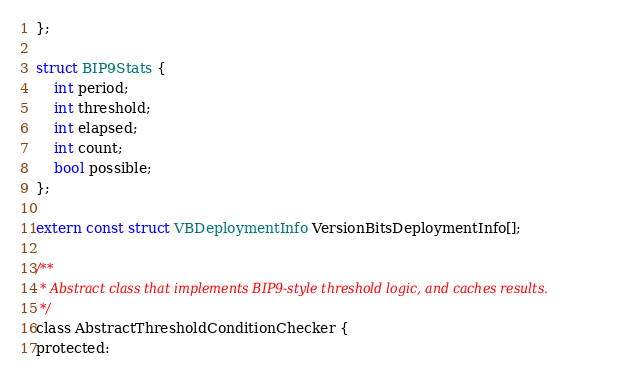Convert code to text. <code><loc_0><loc_0><loc_500><loc_500><_C_>};

struct BIP9Stats {
    int period;
    int threshold;
    int elapsed;
    int count;
    bool possible;
};

extern const struct VBDeploymentInfo VersionBitsDeploymentInfo[];

/**
 * Abstract class that implements BIP9-style threshold logic, and caches results.
 */
class AbstractThresholdConditionChecker {
protected:</code> 